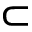Convert formula to latex. <formula><loc_0><loc_0><loc_500><loc_500>\subset</formula> 